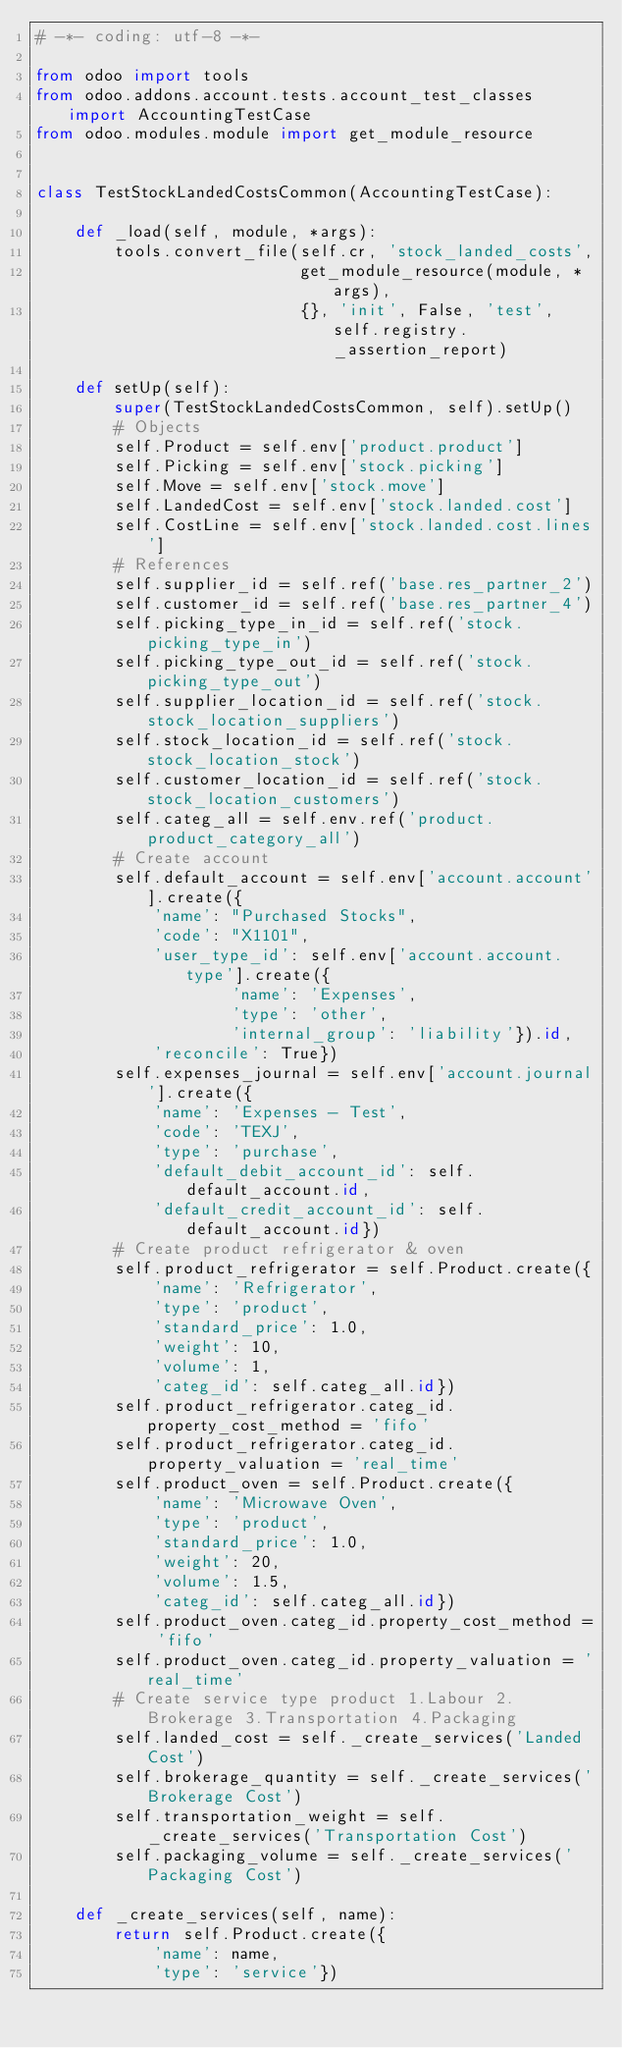Convert code to text. <code><loc_0><loc_0><loc_500><loc_500><_Python_># -*- coding: utf-8 -*-

from odoo import tools
from odoo.addons.account.tests.account_test_classes import AccountingTestCase
from odoo.modules.module import get_module_resource


class TestStockLandedCostsCommon(AccountingTestCase):

    def _load(self, module, *args):
        tools.convert_file(self.cr, 'stock_landed_costs',
                           get_module_resource(module, *args),
                           {}, 'init', False, 'test', self.registry._assertion_report)

    def setUp(self):
        super(TestStockLandedCostsCommon, self).setUp()
        # Objects
        self.Product = self.env['product.product']
        self.Picking = self.env['stock.picking']
        self.Move = self.env['stock.move']
        self.LandedCost = self.env['stock.landed.cost']
        self.CostLine = self.env['stock.landed.cost.lines']
        # References
        self.supplier_id = self.ref('base.res_partner_2')
        self.customer_id = self.ref('base.res_partner_4')
        self.picking_type_in_id = self.ref('stock.picking_type_in')
        self.picking_type_out_id = self.ref('stock.picking_type_out')
        self.supplier_location_id = self.ref('stock.stock_location_suppliers')
        self.stock_location_id = self.ref('stock.stock_location_stock')
        self.customer_location_id = self.ref('stock.stock_location_customers')
        self.categ_all = self.env.ref('product.product_category_all')
        # Create account
        self.default_account = self.env['account.account'].create({
            'name': "Purchased Stocks",
            'code': "X1101",
            'user_type_id': self.env['account.account.type'].create({
                    'name': 'Expenses',
                    'type': 'other',
                    'internal_group': 'liability'}).id,
            'reconcile': True})
        self.expenses_journal = self.env['account.journal'].create({
            'name': 'Expenses - Test',
            'code': 'TEXJ',
            'type': 'purchase',
            'default_debit_account_id': self.default_account.id,
            'default_credit_account_id': self.default_account.id})
        # Create product refrigerator & oven
        self.product_refrigerator = self.Product.create({
            'name': 'Refrigerator',
            'type': 'product',
            'standard_price': 1.0,
            'weight': 10,
            'volume': 1,
            'categ_id': self.categ_all.id})
        self.product_refrigerator.categ_id.property_cost_method = 'fifo'
        self.product_refrigerator.categ_id.property_valuation = 'real_time'
        self.product_oven = self.Product.create({
            'name': 'Microwave Oven',
            'type': 'product',
            'standard_price': 1.0,
            'weight': 20,
            'volume': 1.5,
            'categ_id': self.categ_all.id})
        self.product_oven.categ_id.property_cost_method = 'fifo'
        self.product_oven.categ_id.property_valuation = 'real_time'
        # Create service type product 1.Labour 2.Brokerage 3.Transportation 4.Packaging
        self.landed_cost = self._create_services('Landed Cost')
        self.brokerage_quantity = self._create_services('Brokerage Cost')
        self.transportation_weight = self._create_services('Transportation Cost')
        self.packaging_volume = self._create_services('Packaging Cost')

    def _create_services(self, name):
        return self.Product.create({
            'name': name,
            'type': 'service'})
</code> 